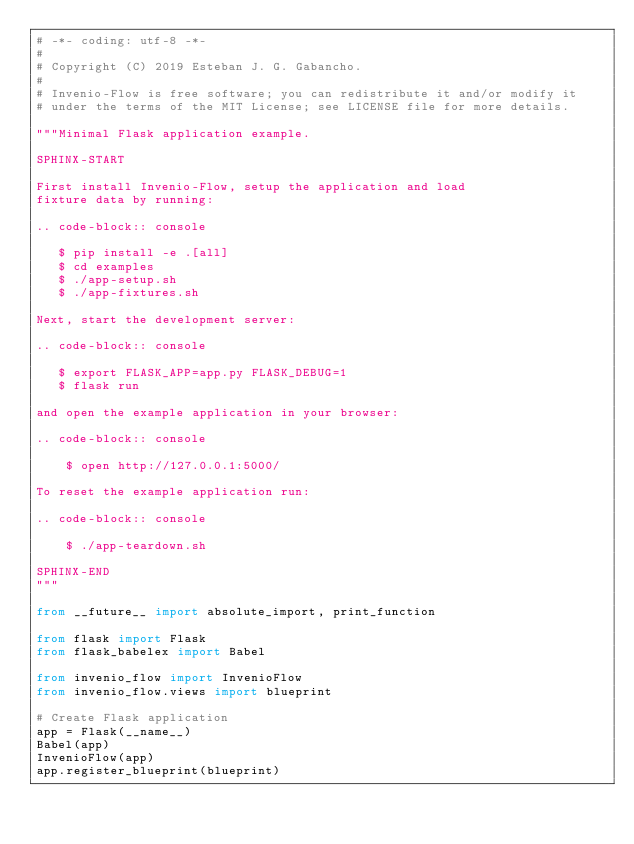<code> <loc_0><loc_0><loc_500><loc_500><_Python_># -*- coding: utf-8 -*-
#
# Copyright (C) 2019 Esteban J. G. Gabancho.
#
# Invenio-Flow is free software; you can redistribute it and/or modify it
# under the terms of the MIT License; see LICENSE file for more details.

"""Minimal Flask application example.

SPHINX-START

First install Invenio-Flow, setup the application and load
fixture data by running:

.. code-block:: console

   $ pip install -e .[all]
   $ cd examples
   $ ./app-setup.sh
   $ ./app-fixtures.sh

Next, start the development server:

.. code-block:: console

   $ export FLASK_APP=app.py FLASK_DEBUG=1
   $ flask run

and open the example application in your browser:

.. code-block:: console

    $ open http://127.0.0.1:5000/

To reset the example application run:

.. code-block:: console

    $ ./app-teardown.sh

SPHINX-END
"""

from __future__ import absolute_import, print_function

from flask import Flask
from flask_babelex import Babel

from invenio_flow import InvenioFlow
from invenio_flow.views import blueprint

# Create Flask application
app = Flask(__name__)
Babel(app)
InvenioFlow(app)
app.register_blueprint(blueprint)
</code> 